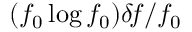Convert formula to latex. <formula><loc_0><loc_0><loc_500><loc_500>( f _ { 0 } \log f _ { 0 } ) \delta \, f / f _ { 0 }</formula> 